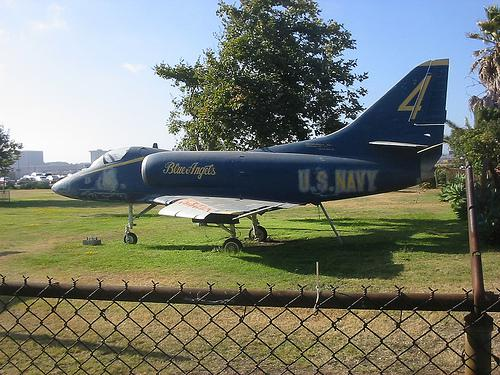Question: who does this plane belong to?
Choices:
A. Delta.
B. United Airline.
C. U.S. Navy.
D. American Airlines.
Answer with the letter. Answer: C Question: where is the large vehicle sitting?
Choices:
A. In the driveway.
B. In the dirt.
C. In the parking lot.
D. In grass.
Answer with the letter. Answer: D Question: what type of vehicle is the large vehicle?
Choices:
A. Van.
B. Boat.
C. Limousine.
D. Airplane.
Answer with the letter. Answer: D Question: what number is shown on tail of airplane?
Choices:
A. 3.
B. 458.
C. 9.
D. 4.
Answer with the letter. Answer: D Question: how are these airplanes powered?
Choices:
A. Turbines.
B. Engines.
C. Propellers.
D. Jet Fuel.
Answer with the letter. Answer: B 